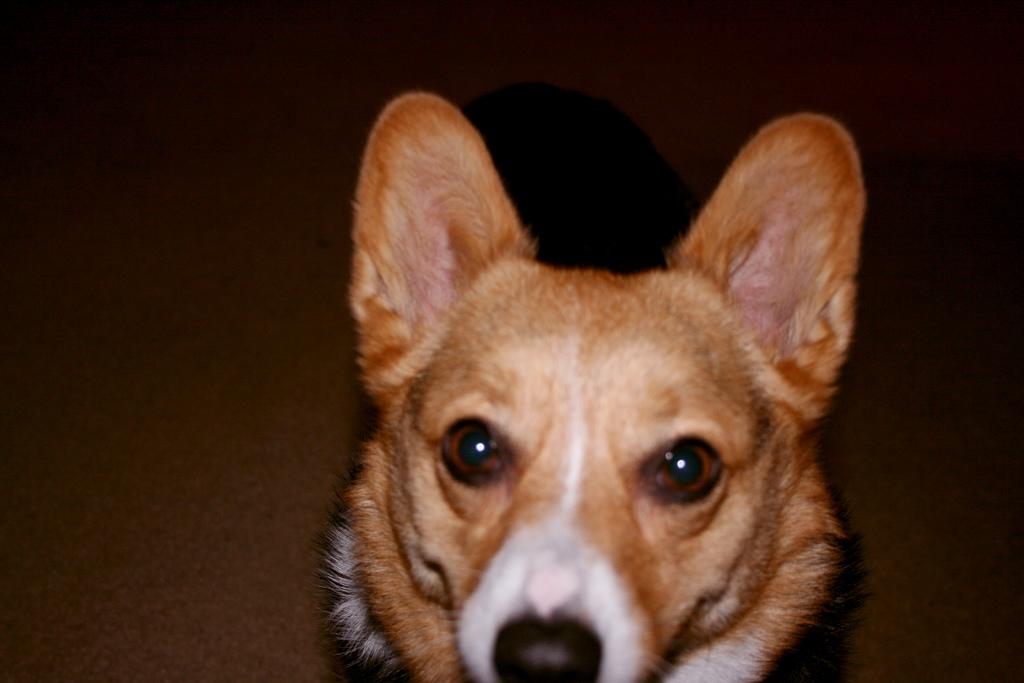What type of animal is in the image? There is a dog in the image. What can be observed about the background of the image? The background of the image is dark. What type of fowl can be seen interacting with the dog in the image? There is no fowl present in the image; it only features a dog. What kind of noise is the dog making in the image? The image does not provide any information about the dog's actions or sounds, so it cannot be determined from the image. 